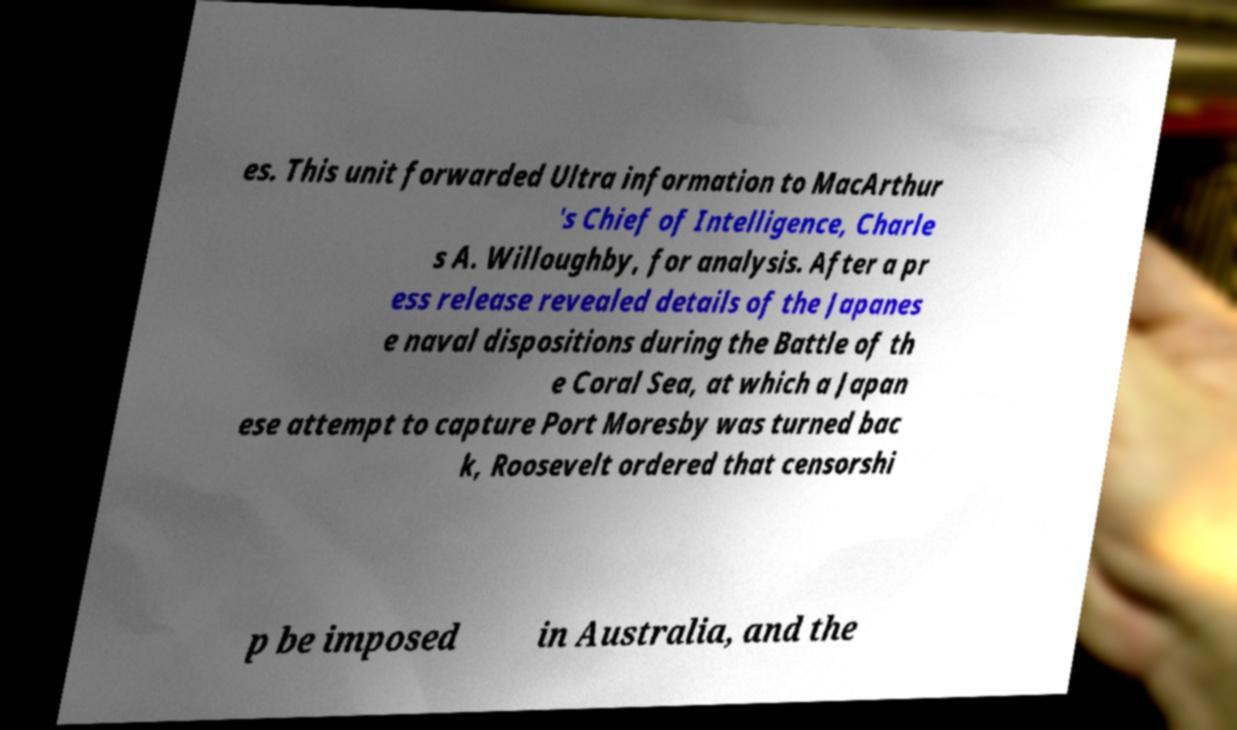Please identify and transcribe the text found in this image. es. This unit forwarded Ultra information to MacArthur 's Chief of Intelligence, Charle s A. Willoughby, for analysis. After a pr ess release revealed details of the Japanes e naval dispositions during the Battle of th e Coral Sea, at which a Japan ese attempt to capture Port Moresby was turned bac k, Roosevelt ordered that censorshi p be imposed in Australia, and the 